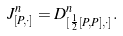<formula> <loc_0><loc_0><loc_500><loc_500>J _ { [ P , \cdot ] } ^ { n } = D _ { [ \frac { 1 } { 2 } [ P , P ] , \cdot ] } ^ { n } .</formula> 